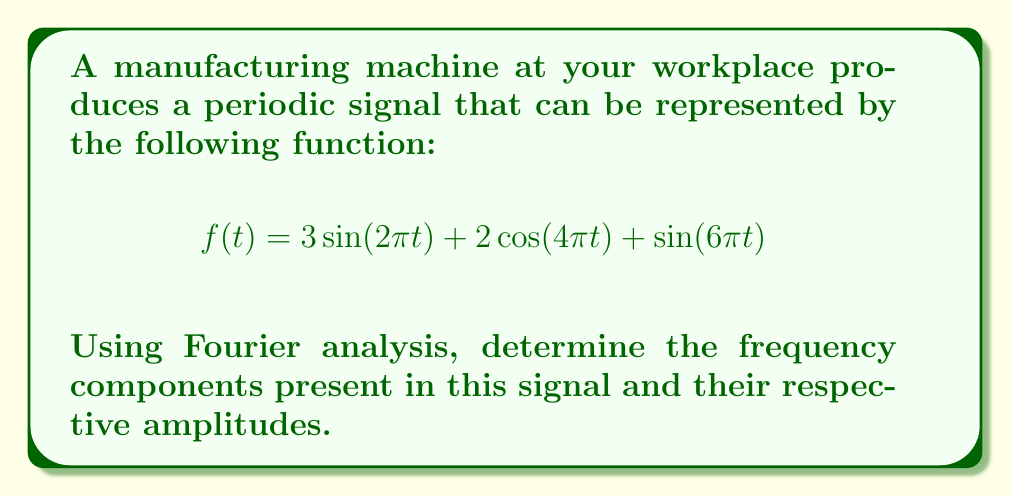What is the answer to this math problem? Let's approach this step-by-step:

1) The Fourier series represents a periodic function as a sum of sine and cosine terms. In this case, we already have the function in this form.

2) The general form of a Fourier series is:

   $$f(t) = A_0 + \sum_{n=1}^{\infty} [A_n \cos(2\pi n f_0 t) + B_n \sin(2\pi n f_0 t)]$$

   where $f_0$ is the fundamental frequency.

3) Comparing our given function to this general form:

   $$f(t) = 3\sin(2\pi t) + 2\cos(4\pi t) + \sin(6\pi t)$$

4) We can identify the following terms:
   - $3\sin(2\pi t)$: This is a sine term with frequency $1$ Hz and amplitude $3$
   - $2\cos(4\pi t)$: This is a cosine term with frequency $2$ Hz and amplitude $2$
   - $\sin(6\pi t)$: This is a sine term with frequency $3$ Hz and amplitude $1$

5) The fundamental frequency $f_0$ is 1 Hz, as this is the greatest common divisor of all the frequencies present.

6) We can now express our findings in terms of frequency components:
   - 1st harmonic (fundamental): 1 Hz, amplitude 3
   - 2nd harmonic: 2 Hz, amplitude 2
   - 3rd harmonic: 3 Hz, amplitude 1
Answer: The frequency components and their amplitudes are:
1 Hz: amplitude 3
2 Hz: amplitude 2
3 Hz: amplitude 1 